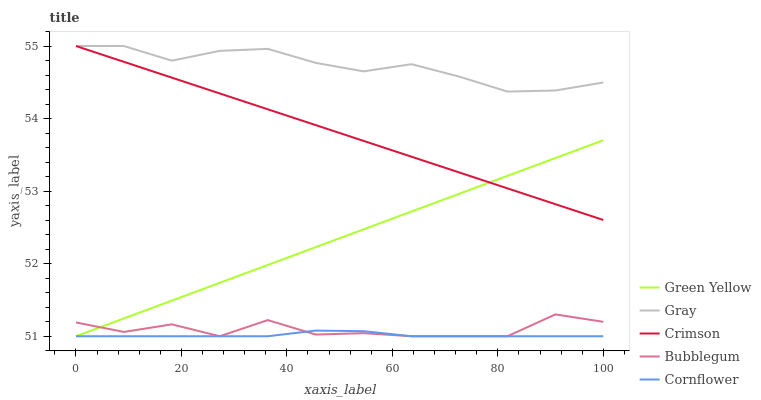Does Green Yellow have the minimum area under the curve?
Answer yes or no. No. Does Green Yellow have the maximum area under the curve?
Answer yes or no. No. Is Gray the smoothest?
Answer yes or no. No. Is Gray the roughest?
Answer yes or no. No. Does Gray have the lowest value?
Answer yes or no. No. Does Green Yellow have the highest value?
Answer yes or no. No. Is Bubblegum less than Crimson?
Answer yes or no. Yes. Is Crimson greater than Bubblegum?
Answer yes or no. Yes. Does Bubblegum intersect Crimson?
Answer yes or no. No. 